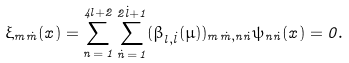<formula> <loc_0><loc_0><loc_500><loc_500>\xi _ { m \dot { m } } ( x ) = \sum _ { n \, = \, 1 } ^ { 4 l + 2 } \sum _ { \dot { n } \, = \, 1 } ^ { 2 \dot { l } + 1 } ( \beta _ { l , \dot { l } } ( \mu ) ) _ { m \dot { m } , n \dot { n } } \psi _ { n \dot { n } } ( x ) = 0 .</formula> 